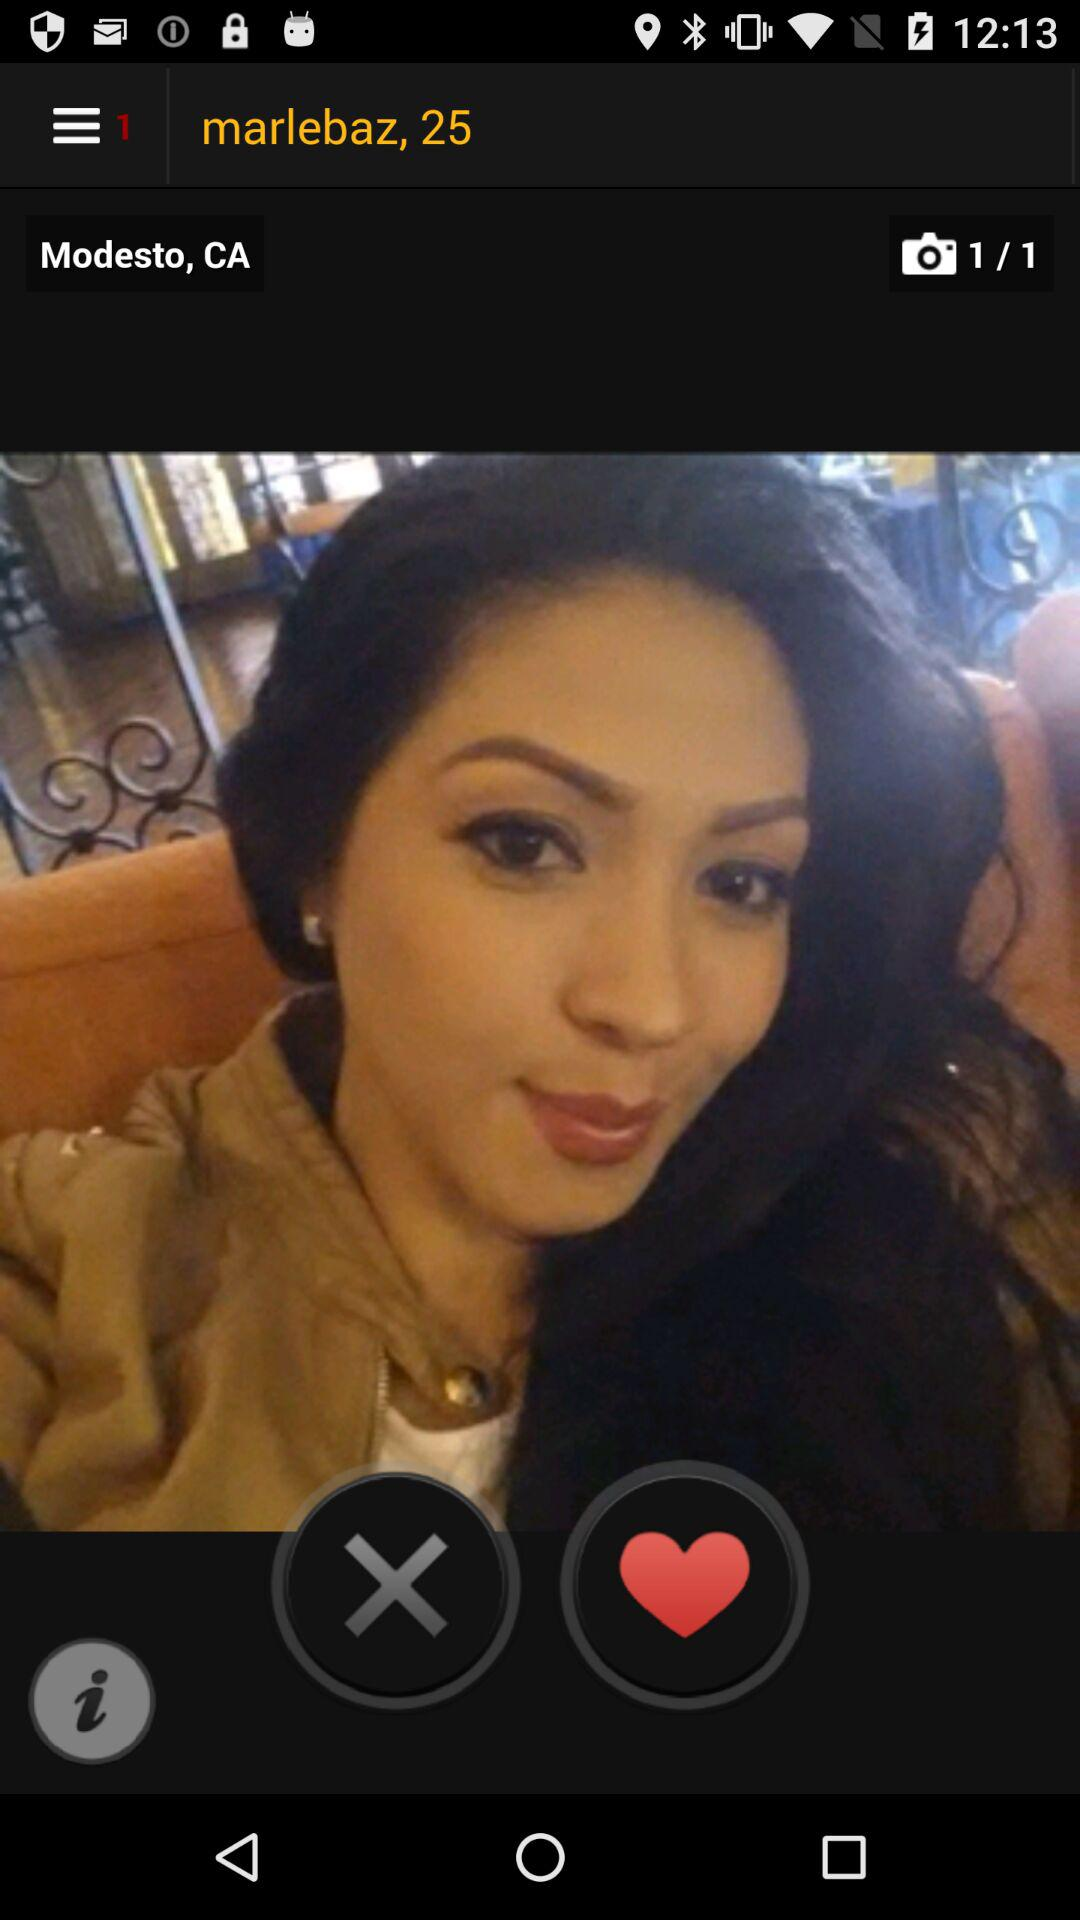What is the total number of photos? The total number of photos is 1. 